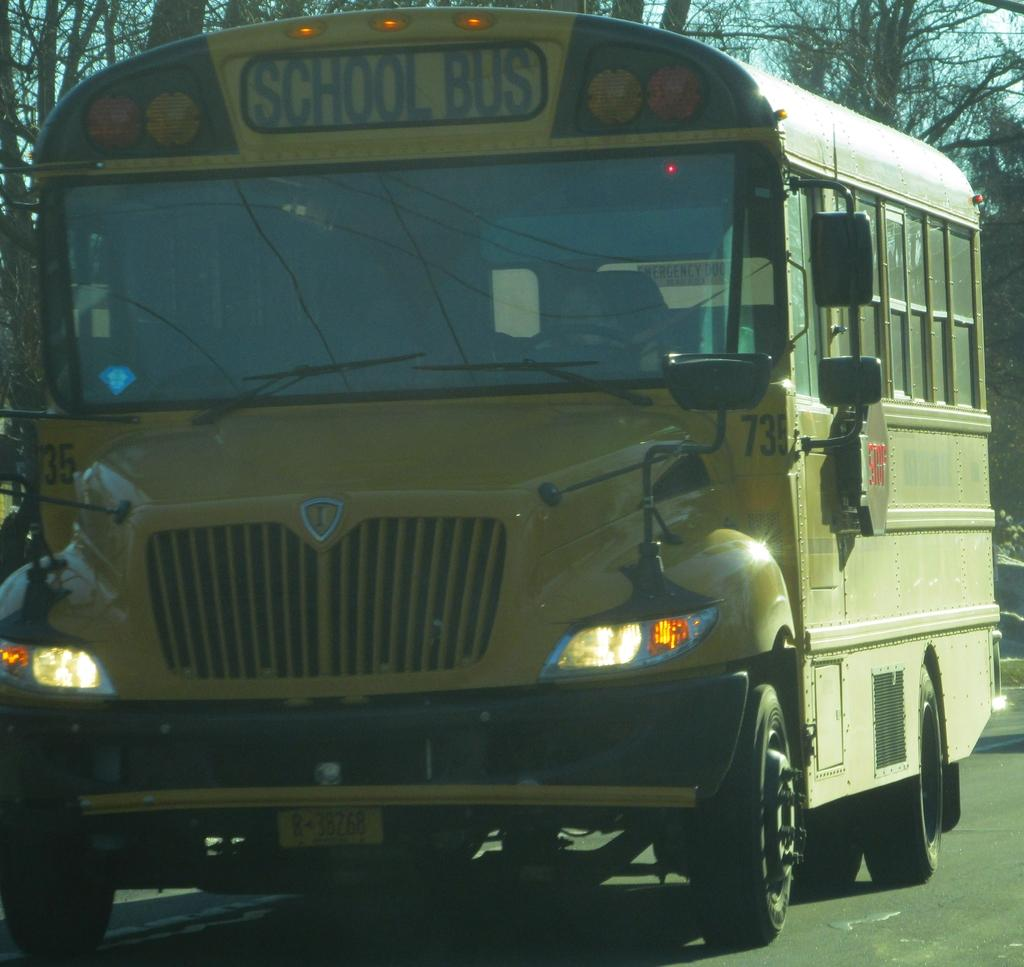What is the main subject of the image? The main subject of the image is a bus. What features can be seen on the bus? The bus has lights and glass windows. Where is the bus located? The bus is on a road. What can be seen in the background of the image? There are trees and the sky visible in the background of the image. Can you tell me how many clouds are depicted in the image? There are no clouds depicted in the image; only the sky is visible in the background. What type of slave is shown working on the bus in the image? There is no slave present in the image; it features a bus on a road with trees and the sky in the background. 